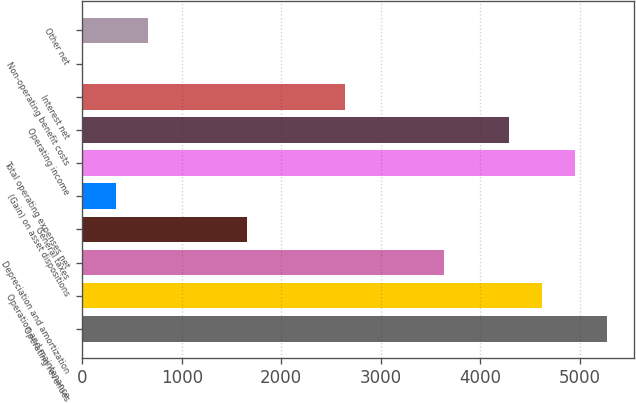Convert chart to OTSL. <chart><loc_0><loc_0><loc_500><loc_500><bar_chart><fcel>Operating revenues<fcel>Operation and maintenance<fcel>Depreciation and amortization<fcel>General taxes<fcel>(Gain) on asset dispositions<fcel>Total operating expenses net<fcel>Operating income<fcel>Interest net<fcel>Non-operating benefit costs<fcel>Other net<nl><fcel>5280.2<fcel>4620.8<fcel>3631.7<fcel>1653.5<fcel>334.7<fcel>4950.5<fcel>4291.1<fcel>2642.6<fcel>5<fcel>664.4<nl></chart> 